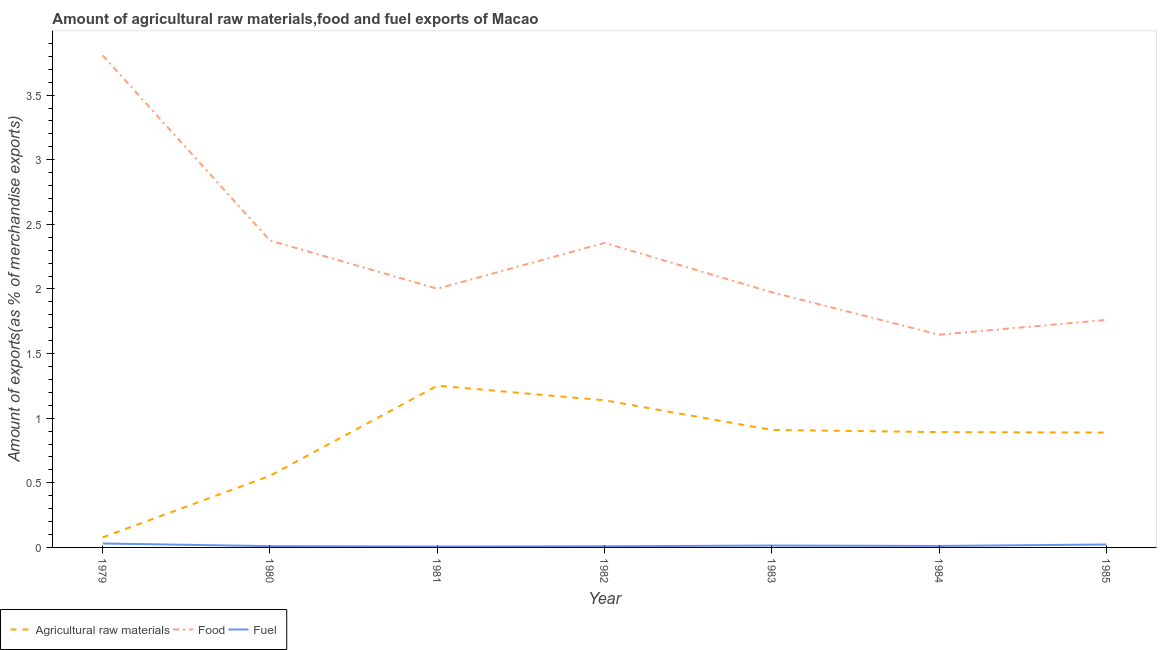Does the line corresponding to percentage of fuel exports intersect with the line corresponding to percentage of raw materials exports?
Offer a very short reply. No. Is the number of lines equal to the number of legend labels?
Your answer should be very brief. Yes. What is the percentage of food exports in 1984?
Offer a terse response. 1.65. Across all years, what is the maximum percentage of fuel exports?
Give a very brief answer. 0.03. Across all years, what is the minimum percentage of fuel exports?
Keep it short and to the point. 0.01. In which year was the percentage of food exports minimum?
Provide a short and direct response. 1984. What is the total percentage of fuel exports in the graph?
Give a very brief answer. 0.1. What is the difference between the percentage of fuel exports in 1982 and that in 1983?
Make the answer very short. -0.01. What is the difference between the percentage of food exports in 1984 and the percentage of raw materials exports in 1979?
Your answer should be very brief. 1.57. What is the average percentage of food exports per year?
Provide a succinct answer. 2.27. In the year 1983, what is the difference between the percentage of raw materials exports and percentage of fuel exports?
Offer a terse response. 0.89. In how many years, is the percentage of raw materials exports greater than 3.5 %?
Provide a succinct answer. 0. What is the ratio of the percentage of fuel exports in 1984 to that in 1985?
Offer a terse response. 0.5. Is the percentage of raw materials exports in 1980 less than that in 1985?
Make the answer very short. Yes. Is the difference between the percentage of fuel exports in 1980 and 1982 greater than the difference between the percentage of raw materials exports in 1980 and 1982?
Your response must be concise. Yes. What is the difference between the highest and the second highest percentage of fuel exports?
Make the answer very short. 0.01. What is the difference between the highest and the lowest percentage of raw materials exports?
Offer a very short reply. 1.17. Does the percentage of fuel exports monotonically increase over the years?
Make the answer very short. No. Is the percentage of food exports strictly greater than the percentage of raw materials exports over the years?
Your response must be concise. Yes. Is the percentage of food exports strictly less than the percentage of raw materials exports over the years?
Offer a very short reply. No. How many lines are there?
Give a very brief answer. 3. How many years are there in the graph?
Keep it short and to the point. 7. What is the difference between two consecutive major ticks on the Y-axis?
Your response must be concise. 0.5. Does the graph contain any zero values?
Provide a succinct answer. No. How many legend labels are there?
Make the answer very short. 3. How are the legend labels stacked?
Provide a succinct answer. Horizontal. What is the title of the graph?
Your response must be concise. Amount of agricultural raw materials,food and fuel exports of Macao. Does "Ages 60+" appear as one of the legend labels in the graph?
Provide a succinct answer. No. What is the label or title of the X-axis?
Provide a short and direct response. Year. What is the label or title of the Y-axis?
Keep it short and to the point. Amount of exports(as % of merchandise exports). What is the Amount of exports(as % of merchandise exports) in Agricultural raw materials in 1979?
Provide a succinct answer. 0.08. What is the Amount of exports(as % of merchandise exports) of Food in 1979?
Give a very brief answer. 3.81. What is the Amount of exports(as % of merchandise exports) in Fuel in 1979?
Ensure brevity in your answer.  0.03. What is the Amount of exports(as % of merchandise exports) in Agricultural raw materials in 1980?
Your answer should be compact. 0.55. What is the Amount of exports(as % of merchandise exports) of Food in 1980?
Offer a very short reply. 2.38. What is the Amount of exports(as % of merchandise exports) in Fuel in 1980?
Your response must be concise. 0.01. What is the Amount of exports(as % of merchandise exports) in Agricultural raw materials in 1981?
Provide a succinct answer. 1.25. What is the Amount of exports(as % of merchandise exports) of Food in 1981?
Keep it short and to the point. 2. What is the Amount of exports(as % of merchandise exports) in Fuel in 1981?
Provide a short and direct response. 0.01. What is the Amount of exports(as % of merchandise exports) of Agricultural raw materials in 1982?
Offer a terse response. 1.14. What is the Amount of exports(as % of merchandise exports) of Food in 1982?
Your answer should be compact. 2.36. What is the Amount of exports(as % of merchandise exports) in Fuel in 1982?
Offer a terse response. 0.01. What is the Amount of exports(as % of merchandise exports) in Agricultural raw materials in 1983?
Your answer should be compact. 0.91. What is the Amount of exports(as % of merchandise exports) of Food in 1983?
Make the answer very short. 1.97. What is the Amount of exports(as % of merchandise exports) of Fuel in 1983?
Provide a succinct answer. 0.01. What is the Amount of exports(as % of merchandise exports) of Agricultural raw materials in 1984?
Make the answer very short. 0.89. What is the Amount of exports(as % of merchandise exports) of Food in 1984?
Your answer should be very brief. 1.65. What is the Amount of exports(as % of merchandise exports) of Fuel in 1984?
Make the answer very short. 0.01. What is the Amount of exports(as % of merchandise exports) in Agricultural raw materials in 1985?
Ensure brevity in your answer.  0.89. What is the Amount of exports(as % of merchandise exports) in Food in 1985?
Your answer should be very brief. 1.76. What is the Amount of exports(as % of merchandise exports) of Fuel in 1985?
Provide a succinct answer. 0.02. Across all years, what is the maximum Amount of exports(as % of merchandise exports) in Agricultural raw materials?
Offer a terse response. 1.25. Across all years, what is the maximum Amount of exports(as % of merchandise exports) of Food?
Ensure brevity in your answer.  3.81. Across all years, what is the maximum Amount of exports(as % of merchandise exports) of Fuel?
Make the answer very short. 0.03. Across all years, what is the minimum Amount of exports(as % of merchandise exports) of Agricultural raw materials?
Offer a terse response. 0.08. Across all years, what is the minimum Amount of exports(as % of merchandise exports) in Food?
Keep it short and to the point. 1.65. Across all years, what is the minimum Amount of exports(as % of merchandise exports) of Fuel?
Give a very brief answer. 0.01. What is the total Amount of exports(as % of merchandise exports) in Agricultural raw materials in the graph?
Keep it short and to the point. 5.71. What is the total Amount of exports(as % of merchandise exports) in Food in the graph?
Ensure brevity in your answer.  15.92. What is the total Amount of exports(as % of merchandise exports) in Fuel in the graph?
Your answer should be compact. 0.1. What is the difference between the Amount of exports(as % of merchandise exports) of Agricultural raw materials in 1979 and that in 1980?
Your answer should be compact. -0.48. What is the difference between the Amount of exports(as % of merchandise exports) of Food in 1979 and that in 1980?
Provide a succinct answer. 1.43. What is the difference between the Amount of exports(as % of merchandise exports) in Fuel in 1979 and that in 1980?
Keep it short and to the point. 0.02. What is the difference between the Amount of exports(as % of merchandise exports) in Agricultural raw materials in 1979 and that in 1981?
Your answer should be compact. -1.17. What is the difference between the Amount of exports(as % of merchandise exports) of Food in 1979 and that in 1981?
Your answer should be compact. 1.81. What is the difference between the Amount of exports(as % of merchandise exports) in Fuel in 1979 and that in 1981?
Give a very brief answer. 0.02. What is the difference between the Amount of exports(as % of merchandise exports) in Agricultural raw materials in 1979 and that in 1982?
Ensure brevity in your answer.  -1.06. What is the difference between the Amount of exports(as % of merchandise exports) of Food in 1979 and that in 1982?
Your answer should be compact. 1.45. What is the difference between the Amount of exports(as % of merchandise exports) of Fuel in 1979 and that in 1982?
Offer a very short reply. 0.02. What is the difference between the Amount of exports(as % of merchandise exports) in Agricultural raw materials in 1979 and that in 1983?
Your response must be concise. -0.83. What is the difference between the Amount of exports(as % of merchandise exports) of Food in 1979 and that in 1983?
Your answer should be very brief. 1.83. What is the difference between the Amount of exports(as % of merchandise exports) of Fuel in 1979 and that in 1983?
Provide a succinct answer. 0.02. What is the difference between the Amount of exports(as % of merchandise exports) in Agricultural raw materials in 1979 and that in 1984?
Ensure brevity in your answer.  -0.81. What is the difference between the Amount of exports(as % of merchandise exports) in Food in 1979 and that in 1984?
Your response must be concise. 2.16. What is the difference between the Amount of exports(as % of merchandise exports) in Fuel in 1979 and that in 1984?
Your answer should be very brief. 0.02. What is the difference between the Amount of exports(as % of merchandise exports) of Agricultural raw materials in 1979 and that in 1985?
Your answer should be compact. -0.81. What is the difference between the Amount of exports(as % of merchandise exports) of Food in 1979 and that in 1985?
Keep it short and to the point. 2.05. What is the difference between the Amount of exports(as % of merchandise exports) of Fuel in 1979 and that in 1985?
Offer a terse response. 0.01. What is the difference between the Amount of exports(as % of merchandise exports) of Agricultural raw materials in 1980 and that in 1981?
Ensure brevity in your answer.  -0.7. What is the difference between the Amount of exports(as % of merchandise exports) in Food in 1980 and that in 1981?
Give a very brief answer. 0.37. What is the difference between the Amount of exports(as % of merchandise exports) in Fuel in 1980 and that in 1981?
Your answer should be very brief. 0. What is the difference between the Amount of exports(as % of merchandise exports) in Agricultural raw materials in 1980 and that in 1982?
Offer a very short reply. -0.58. What is the difference between the Amount of exports(as % of merchandise exports) in Food in 1980 and that in 1982?
Offer a very short reply. 0.02. What is the difference between the Amount of exports(as % of merchandise exports) of Fuel in 1980 and that in 1982?
Provide a succinct answer. 0. What is the difference between the Amount of exports(as % of merchandise exports) of Agricultural raw materials in 1980 and that in 1983?
Offer a very short reply. -0.36. What is the difference between the Amount of exports(as % of merchandise exports) in Food in 1980 and that in 1983?
Provide a succinct answer. 0.4. What is the difference between the Amount of exports(as % of merchandise exports) of Fuel in 1980 and that in 1983?
Provide a succinct answer. -0. What is the difference between the Amount of exports(as % of merchandise exports) of Agricultural raw materials in 1980 and that in 1984?
Provide a short and direct response. -0.34. What is the difference between the Amount of exports(as % of merchandise exports) in Food in 1980 and that in 1984?
Your answer should be very brief. 0.73. What is the difference between the Amount of exports(as % of merchandise exports) of Fuel in 1980 and that in 1984?
Give a very brief answer. -0. What is the difference between the Amount of exports(as % of merchandise exports) in Agricultural raw materials in 1980 and that in 1985?
Offer a very short reply. -0.33. What is the difference between the Amount of exports(as % of merchandise exports) of Food in 1980 and that in 1985?
Provide a succinct answer. 0.61. What is the difference between the Amount of exports(as % of merchandise exports) in Fuel in 1980 and that in 1985?
Your response must be concise. -0.01. What is the difference between the Amount of exports(as % of merchandise exports) of Agricultural raw materials in 1981 and that in 1982?
Your response must be concise. 0.11. What is the difference between the Amount of exports(as % of merchandise exports) in Food in 1981 and that in 1982?
Make the answer very short. -0.35. What is the difference between the Amount of exports(as % of merchandise exports) of Fuel in 1981 and that in 1982?
Give a very brief answer. -0. What is the difference between the Amount of exports(as % of merchandise exports) of Agricultural raw materials in 1981 and that in 1983?
Your response must be concise. 0.34. What is the difference between the Amount of exports(as % of merchandise exports) in Food in 1981 and that in 1983?
Make the answer very short. 0.03. What is the difference between the Amount of exports(as % of merchandise exports) of Fuel in 1981 and that in 1983?
Your answer should be very brief. -0.01. What is the difference between the Amount of exports(as % of merchandise exports) in Agricultural raw materials in 1981 and that in 1984?
Your answer should be very brief. 0.36. What is the difference between the Amount of exports(as % of merchandise exports) of Food in 1981 and that in 1984?
Give a very brief answer. 0.36. What is the difference between the Amount of exports(as % of merchandise exports) in Fuel in 1981 and that in 1984?
Keep it short and to the point. -0. What is the difference between the Amount of exports(as % of merchandise exports) of Agricultural raw materials in 1981 and that in 1985?
Ensure brevity in your answer.  0.36. What is the difference between the Amount of exports(as % of merchandise exports) of Food in 1981 and that in 1985?
Offer a very short reply. 0.24. What is the difference between the Amount of exports(as % of merchandise exports) in Fuel in 1981 and that in 1985?
Offer a very short reply. -0.02. What is the difference between the Amount of exports(as % of merchandise exports) in Agricultural raw materials in 1982 and that in 1983?
Offer a very short reply. 0.23. What is the difference between the Amount of exports(as % of merchandise exports) of Food in 1982 and that in 1983?
Offer a terse response. 0.38. What is the difference between the Amount of exports(as % of merchandise exports) in Fuel in 1982 and that in 1983?
Provide a succinct answer. -0.01. What is the difference between the Amount of exports(as % of merchandise exports) of Agricultural raw materials in 1982 and that in 1984?
Give a very brief answer. 0.25. What is the difference between the Amount of exports(as % of merchandise exports) of Food in 1982 and that in 1984?
Your answer should be very brief. 0.71. What is the difference between the Amount of exports(as % of merchandise exports) of Fuel in 1982 and that in 1984?
Ensure brevity in your answer.  -0. What is the difference between the Amount of exports(as % of merchandise exports) of Agricultural raw materials in 1982 and that in 1985?
Provide a succinct answer. 0.25. What is the difference between the Amount of exports(as % of merchandise exports) of Food in 1982 and that in 1985?
Keep it short and to the point. 0.6. What is the difference between the Amount of exports(as % of merchandise exports) of Fuel in 1982 and that in 1985?
Keep it short and to the point. -0.01. What is the difference between the Amount of exports(as % of merchandise exports) of Agricultural raw materials in 1983 and that in 1984?
Ensure brevity in your answer.  0.02. What is the difference between the Amount of exports(as % of merchandise exports) in Food in 1983 and that in 1984?
Your response must be concise. 0.33. What is the difference between the Amount of exports(as % of merchandise exports) in Fuel in 1983 and that in 1984?
Provide a short and direct response. 0. What is the difference between the Amount of exports(as % of merchandise exports) in Agricultural raw materials in 1983 and that in 1985?
Give a very brief answer. 0.02. What is the difference between the Amount of exports(as % of merchandise exports) in Food in 1983 and that in 1985?
Provide a succinct answer. 0.21. What is the difference between the Amount of exports(as % of merchandise exports) in Fuel in 1983 and that in 1985?
Give a very brief answer. -0.01. What is the difference between the Amount of exports(as % of merchandise exports) in Agricultural raw materials in 1984 and that in 1985?
Your response must be concise. 0. What is the difference between the Amount of exports(as % of merchandise exports) in Food in 1984 and that in 1985?
Keep it short and to the point. -0.11. What is the difference between the Amount of exports(as % of merchandise exports) of Fuel in 1984 and that in 1985?
Your response must be concise. -0.01. What is the difference between the Amount of exports(as % of merchandise exports) in Agricultural raw materials in 1979 and the Amount of exports(as % of merchandise exports) in Food in 1980?
Offer a terse response. -2.3. What is the difference between the Amount of exports(as % of merchandise exports) in Agricultural raw materials in 1979 and the Amount of exports(as % of merchandise exports) in Fuel in 1980?
Offer a terse response. 0.07. What is the difference between the Amount of exports(as % of merchandise exports) of Food in 1979 and the Amount of exports(as % of merchandise exports) of Fuel in 1980?
Your answer should be very brief. 3.8. What is the difference between the Amount of exports(as % of merchandise exports) of Agricultural raw materials in 1979 and the Amount of exports(as % of merchandise exports) of Food in 1981?
Your answer should be compact. -1.92. What is the difference between the Amount of exports(as % of merchandise exports) in Agricultural raw materials in 1979 and the Amount of exports(as % of merchandise exports) in Fuel in 1981?
Give a very brief answer. 0.07. What is the difference between the Amount of exports(as % of merchandise exports) in Food in 1979 and the Amount of exports(as % of merchandise exports) in Fuel in 1981?
Give a very brief answer. 3.8. What is the difference between the Amount of exports(as % of merchandise exports) of Agricultural raw materials in 1979 and the Amount of exports(as % of merchandise exports) of Food in 1982?
Give a very brief answer. -2.28. What is the difference between the Amount of exports(as % of merchandise exports) in Agricultural raw materials in 1979 and the Amount of exports(as % of merchandise exports) in Fuel in 1982?
Your answer should be compact. 0.07. What is the difference between the Amount of exports(as % of merchandise exports) of Food in 1979 and the Amount of exports(as % of merchandise exports) of Fuel in 1982?
Make the answer very short. 3.8. What is the difference between the Amount of exports(as % of merchandise exports) in Agricultural raw materials in 1979 and the Amount of exports(as % of merchandise exports) in Food in 1983?
Offer a terse response. -1.9. What is the difference between the Amount of exports(as % of merchandise exports) in Agricultural raw materials in 1979 and the Amount of exports(as % of merchandise exports) in Fuel in 1983?
Offer a terse response. 0.06. What is the difference between the Amount of exports(as % of merchandise exports) of Food in 1979 and the Amount of exports(as % of merchandise exports) of Fuel in 1983?
Give a very brief answer. 3.79. What is the difference between the Amount of exports(as % of merchandise exports) of Agricultural raw materials in 1979 and the Amount of exports(as % of merchandise exports) of Food in 1984?
Your answer should be compact. -1.57. What is the difference between the Amount of exports(as % of merchandise exports) in Agricultural raw materials in 1979 and the Amount of exports(as % of merchandise exports) in Fuel in 1984?
Make the answer very short. 0.07. What is the difference between the Amount of exports(as % of merchandise exports) of Food in 1979 and the Amount of exports(as % of merchandise exports) of Fuel in 1984?
Provide a succinct answer. 3.8. What is the difference between the Amount of exports(as % of merchandise exports) in Agricultural raw materials in 1979 and the Amount of exports(as % of merchandise exports) in Food in 1985?
Offer a terse response. -1.68. What is the difference between the Amount of exports(as % of merchandise exports) in Agricultural raw materials in 1979 and the Amount of exports(as % of merchandise exports) in Fuel in 1985?
Your answer should be compact. 0.06. What is the difference between the Amount of exports(as % of merchandise exports) of Food in 1979 and the Amount of exports(as % of merchandise exports) of Fuel in 1985?
Offer a terse response. 3.79. What is the difference between the Amount of exports(as % of merchandise exports) in Agricultural raw materials in 1980 and the Amount of exports(as % of merchandise exports) in Food in 1981?
Offer a terse response. -1.45. What is the difference between the Amount of exports(as % of merchandise exports) of Agricultural raw materials in 1980 and the Amount of exports(as % of merchandise exports) of Fuel in 1981?
Offer a terse response. 0.55. What is the difference between the Amount of exports(as % of merchandise exports) of Food in 1980 and the Amount of exports(as % of merchandise exports) of Fuel in 1981?
Your answer should be compact. 2.37. What is the difference between the Amount of exports(as % of merchandise exports) of Agricultural raw materials in 1980 and the Amount of exports(as % of merchandise exports) of Food in 1982?
Ensure brevity in your answer.  -1.8. What is the difference between the Amount of exports(as % of merchandise exports) in Agricultural raw materials in 1980 and the Amount of exports(as % of merchandise exports) in Fuel in 1982?
Keep it short and to the point. 0.54. What is the difference between the Amount of exports(as % of merchandise exports) in Food in 1980 and the Amount of exports(as % of merchandise exports) in Fuel in 1982?
Ensure brevity in your answer.  2.37. What is the difference between the Amount of exports(as % of merchandise exports) in Agricultural raw materials in 1980 and the Amount of exports(as % of merchandise exports) in Food in 1983?
Offer a terse response. -1.42. What is the difference between the Amount of exports(as % of merchandise exports) in Agricultural raw materials in 1980 and the Amount of exports(as % of merchandise exports) in Fuel in 1983?
Provide a short and direct response. 0.54. What is the difference between the Amount of exports(as % of merchandise exports) in Food in 1980 and the Amount of exports(as % of merchandise exports) in Fuel in 1983?
Offer a terse response. 2.36. What is the difference between the Amount of exports(as % of merchandise exports) of Agricultural raw materials in 1980 and the Amount of exports(as % of merchandise exports) of Food in 1984?
Give a very brief answer. -1.09. What is the difference between the Amount of exports(as % of merchandise exports) of Agricultural raw materials in 1980 and the Amount of exports(as % of merchandise exports) of Fuel in 1984?
Provide a succinct answer. 0.54. What is the difference between the Amount of exports(as % of merchandise exports) of Food in 1980 and the Amount of exports(as % of merchandise exports) of Fuel in 1984?
Offer a very short reply. 2.36. What is the difference between the Amount of exports(as % of merchandise exports) in Agricultural raw materials in 1980 and the Amount of exports(as % of merchandise exports) in Food in 1985?
Provide a succinct answer. -1.21. What is the difference between the Amount of exports(as % of merchandise exports) of Agricultural raw materials in 1980 and the Amount of exports(as % of merchandise exports) of Fuel in 1985?
Your answer should be very brief. 0.53. What is the difference between the Amount of exports(as % of merchandise exports) in Food in 1980 and the Amount of exports(as % of merchandise exports) in Fuel in 1985?
Provide a succinct answer. 2.35. What is the difference between the Amount of exports(as % of merchandise exports) in Agricultural raw materials in 1981 and the Amount of exports(as % of merchandise exports) in Food in 1982?
Give a very brief answer. -1.1. What is the difference between the Amount of exports(as % of merchandise exports) of Agricultural raw materials in 1981 and the Amount of exports(as % of merchandise exports) of Fuel in 1982?
Keep it short and to the point. 1.24. What is the difference between the Amount of exports(as % of merchandise exports) in Food in 1981 and the Amount of exports(as % of merchandise exports) in Fuel in 1982?
Your response must be concise. 1.99. What is the difference between the Amount of exports(as % of merchandise exports) in Agricultural raw materials in 1981 and the Amount of exports(as % of merchandise exports) in Food in 1983?
Provide a short and direct response. -0.72. What is the difference between the Amount of exports(as % of merchandise exports) in Agricultural raw materials in 1981 and the Amount of exports(as % of merchandise exports) in Fuel in 1983?
Offer a terse response. 1.24. What is the difference between the Amount of exports(as % of merchandise exports) in Food in 1981 and the Amount of exports(as % of merchandise exports) in Fuel in 1983?
Offer a terse response. 1.99. What is the difference between the Amount of exports(as % of merchandise exports) in Agricultural raw materials in 1981 and the Amount of exports(as % of merchandise exports) in Food in 1984?
Give a very brief answer. -0.39. What is the difference between the Amount of exports(as % of merchandise exports) in Agricultural raw materials in 1981 and the Amount of exports(as % of merchandise exports) in Fuel in 1984?
Provide a short and direct response. 1.24. What is the difference between the Amount of exports(as % of merchandise exports) of Food in 1981 and the Amount of exports(as % of merchandise exports) of Fuel in 1984?
Give a very brief answer. 1.99. What is the difference between the Amount of exports(as % of merchandise exports) of Agricultural raw materials in 1981 and the Amount of exports(as % of merchandise exports) of Food in 1985?
Keep it short and to the point. -0.51. What is the difference between the Amount of exports(as % of merchandise exports) of Agricultural raw materials in 1981 and the Amount of exports(as % of merchandise exports) of Fuel in 1985?
Keep it short and to the point. 1.23. What is the difference between the Amount of exports(as % of merchandise exports) in Food in 1981 and the Amount of exports(as % of merchandise exports) in Fuel in 1985?
Keep it short and to the point. 1.98. What is the difference between the Amount of exports(as % of merchandise exports) of Agricultural raw materials in 1982 and the Amount of exports(as % of merchandise exports) of Food in 1983?
Keep it short and to the point. -0.84. What is the difference between the Amount of exports(as % of merchandise exports) in Agricultural raw materials in 1982 and the Amount of exports(as % of merchandise exports) in Fuel in 1983?
Your response must be concise. 1.12. What is the difference between the Amount of exports(as % of merchandise exports) of Food in 1982 and the Amount of exports(as % of merchandise exports) of Fuel in 1983?
Offer a very short reply. 2.34. What is the difference between the Amount of exports(as % of merchandise exports) of Agricultural raw materials in 1982 and the Amount of exports(as % of merchandise exports) of Food in 1984?
Ensure brevity in your answer.  -0.51. What is the difference between the Amount of exports(as % of merchandise exports) of Agricultural raw materials in 1982 and the Amount of exports(as % of merchandise exports) of Fuel in 1984?
Ensure brevity in your answer.  1.13. What is the difference between the Amount of exports(as % of merchandise exports) of Food in 1982 and the Amount of exports(as % of merchandise exports) of Fuel in 1984?
Offer a very short reply. 2.35. What is the difference between the Amount of exports(as % of merchandise exports) in Agricultural raw materials in 1982 and the Amount of exports(as % of merchandise exports) in Food in 1985?
Provide a short and direct response. -0.62. What is the difference between the Amount of exports(as % of merchandise exports) of Agricultural raw materials in 1982 and the Amount of exports(as % of merchandise exports) of Fuel in 1985?
Give a very brief answer. 1.12. What is the difference between the Amount of exports(as % of merchandise exports) of Food in 1982 and the Amount of exports(as % of merchandise exports) of Fuel in 1985?
Your answer should be very brief. 2.33. What is the difference between the Amount of exports(as % of merchandise exports) of Agricultural raw materials in 1983 and the Amount of exports(as % of merchandise exports) of Food in 1984?
Provide a short and direct response. -0.74. What is the difference between the Amount of exports(as % of merchandise exports) in Agricultural raw materials in 1983 and the Amount of exports(as % of merchandise exports) in Fuel in 1984?
Provide a short and direct response. 0.9. What is the difference between the Amount of exports(as % of merchandise exports) of Food in 1983 and the Amount of exports(as % of merchandise exports) of Fuel in 1984?
Offer a terse response. 1.96. What is the difference between the Amount of exports(as % of merchandise exports) in Agricultural raw materials in 1983 and the Amount of exports(as % of merchandise exports) in Food in 1985?
Keep it short and to the point. -0.85. What is the difference between the Amount of exports(as % of merchandise exports) of Agricultural raw materials in 1983 and the Amount of exports(as % of merchandise exports) of Fuel in 1985?
Ensure brevity in your answer.  0.89. What is the difference between the Amount of exports(as % of merchandise exports) of Food in 1983 and the Amount of exports(as % of merchandise exports) of Fuel in 1985?
Provide a succinct answer. 1.95. What is the difference between the Amount of exports(as % of merchandise exports) in Agricultural raw materials in 1984 and the Amount of exports(as % of merchandise exports) in Food in 1985?
Your answer should be very brief. -0.87. What is the difference between the Amount of exports(as % of merchandise exports) of Agricultural raw materials in 1984 and the Amount of exports(as % of merchandise exports) of Fuel in 1985?
Offer a very short reply. 0.87. What is the difference between the Amount of exports(as % of merchandise exports) of Food in 1984 and the Amount of exports(as % of merchandise exports) of Fuel in 1985?
Your response must be concise. 1.62. What is the average Amount of exports(as % of merchandise exports) of Agricultural raw materials per year?
Keep it short and to the point. 0.82. What is the average Amount of exports(as % of merchandise exports) of Food per year?
Give a very brief answer. 2.27. What is the average Amount of exports(as % of merchandise exports) in Fuel per year?
Keep it short and to the point. 0.01. In the year 1979, what is the difference between the Amount of exports(as % of merchandise exports) of Agricultural raw materials and Amount of exports(as % of merchandise exports) of Food?
Offer a very short reply. -3.73. In the year 1979, what is the difference between the Amount of exports(as % of merchandise exports) in Agricultural raw materials and Amount of exports(as % of merchandise exports) in Fuel?
Your response must be concise. 0.05. In the year 1979, what is the difference between the Amount of exports(as % of merchandise exports) of Food and Amount of exports(as % of merchandise exports) of Fuel?
Provide a succinct answer. 3.78. In the year 1980, what is the difference between the Amount of exports(as % of merchandise exports) in Agricultural raw materials and Amount of exports(as % of merchandise exports) in Food?
Make the answer very short. -1.82. In the year 1980, what is the difference between the Amount of exports(as % of merchandise exports) of Agricultural raw materials and Amount of exports(as % of merchandise exports) of Fuel?
Offer a terse response. 0.54. In the year 1980, what is the difference between the Amount of exports(as % of merchandise exports) in Food and Amount of exports(as % of merchandise exports) in Fuel?
Your answer should be very brief. 2.37. In the year 1981, what is the difference between the Amount of exports(as % of merchandise exports) of Agricultural raw materials and Amount of exports(as % of merchandise exports) of Food?
Keep it short and to the point. -0.75. In the year 1981, what is the difference between the Amount of exports(as % of merchandise exports) in Agricultural raw materials and Amount of exports(as % of merchandise exports) in Fuel?
Your answer should be very brief. 1.24. In the year 1981, what is the difference between the Amount of exports(as % of merchandise exports) of Food and Amount of exports(as % of merchandise exports) of Fuel?
Offer a terse response. 2. In the year 1982, what is the difference between the Amount of exports(as % of merchandise exports) in Agricultural raw materials and Amount of exports(as % of merchandise exports) in Food?
Make the answer very short. -1.22. In the year 1982, what is the difference between the Amount of exports(as % of merchandise exports) in Agricultural raw materials and Amount of exports(as % of merchandise exports) in Fuel?
Provide a short and direct response. 1.13. In the year 1982, what is the difference between the Amount of exports(as % of merchandise exports) in Food and Amount of exports(as % of merchandise exports) in Fuel?
Ensure brevity in your answer.  2.35. In the year 1983, what is the difference between the Amount of exports(as % of merchandise exports) in Agricultural raw materials and Amount of exports(as % of merchandise exports) in Food?
Your response must be concise. -1.07. In the year 1983, what is the difference between the Amount of exports(as % of merchandise exports) in Agricultural raw materials and Amount of exports(as % of merchandise exports) in Fuel?
Keep it short and to the point. 0.89. In the year 1983, what is the difference between the Amount of exports(as % of merchandise exports) in Food and Amount of exports(as % of merchandise exports) in Fuel?
Offer a very short reply. 1.96. In the year 1984, what is the difference between the Amount of exports(as % of merchandise exports) of Agricultural raw materials and Amount of exports(as % of merchandise exports) of Food?
Your answer should be very brief. -0.75. In the year 1984, what is the difference between the Amount of exports(as % of merchandise exports) of Agricultural raw materials and Amount of exports(as % of merchandise exports) of Fuel?
Provide a succinct answer. 0.88. In the year 1984, what is the difference between the Amount of exports(as % of merchandise exports) in Food and Amount of exports(as % of merchandise exports) in Fuel?
Provide a short and direct response. 1.63. In the year 1985, what is the difference between the Amount of exports(as % of merchandise exports) in Agricultural raw materials and Amount of exports(as % of merchandise exports) in Food?
Keep it short and to the point. -0.87. In the year 1985, what is the difference between the Amount of exports(as % of merchandise exports) of Agricultural raw materials and Amount of exports(as % of merchandise exports) of Fuel?
Ensure brevity in your answer.  0.87. In the year 1985, what is the difference between the Amount of exports(as % of merchandise exports) in Food and Amount of exports(as % of merchandise exports) in Fuel?
Give a very brief answer. 1.74. What is the ratio of the Amount of exports(as % of merchandise exports) of Agricultural raw materials in 1979 to that in 1980?
Offer a terse response. 0.14. What is the ratio of the Amount of exports(as % of merchandise exports) in Food in 1979 to that in 1980?
Ensure brevity in your answer.  1.6. What is the ratio of the Amount of exports(as % of merchandise exports) of Fuel in 1979 to that in 1980?
Your answer should be compact. 3.03. What is the ratio of the Amount of exports(as % of merchandise exports) in Agricultural raw materials in 1979 to that in 1981?
Offer a very short reply. 0.06. What is the ratio of the Amount of exports(as % of merchandise exports) of Food in 1979 to that in 1981?
Your answer should be very brief. 1.9. What is the ratio of the Amount of exports(as % of merchandise exports) of Fuel in 1979 to that in 1981?
Your answer should be compact. 4.42. What is the ratio of the Amount of exports(as % of merchandise exports) of Agricultural raw materials in 1979 to that in 1982?
Make the answer very short. 0.07. What is the ratio of the Amount of exports(as % of merchandise exports) in Food in 1979 to that in 1982?
Give a very brief answer. 1.62. What is the ratio of the Amount of exports(as % of merchandise exports) in Fuel in 1979 to that in 1982?
Keep it short and to the point. 3.4. What is the ratio of the Amount of exports(as % of merchandise exports) in Agricultural raw materials in 1979 to that in 1983?
Make the answer very short. 0.09. What is the ratio of the Amount of exports(as % of merchandise exports) of Food in 1979 to that in 1983?
Give a very brief answer. 1.93. What is the ratio of the Amount of exports(as % of merchandise exports) in Fuel in 1979 to that in 1983?
Your response must be concise. 2.09. What is the ratio of the Amount of exports(as % of merchandise exports) in Agricultural raw materials in 1979 to that in 1984?
Make the answer very short. 0.09. What is the ratio of the Amount of exports(as % of merchandise exports) in Food in 1979 to that in 1984?
Offer a very short reply. 2.31. What is the ratio of the Amount of exports(as % of merchandise exports) of Fuel in 1979 to that in 1984?
Provide a short and direct response. 2.68. What is the ratio of the Amount of exports(as % of merchandise exports) of Agricultural raw materials in 1979 to that in 1985?
Provide a short and direct response. 0.09. What is the ratio of the Amount of exports(as % of merchandise exports) in Food in 1979 to that in 1985?
Give a very brief answer. 2.16. What is the ratio of the Amount of exports(as % of merchandise exports) of Fuel in 1979 to that in 1985?
Ensure brevity in your answer.  1.34. What is the ratio of the Amount of exports(as % of merchandise exports) in Agricultural raw materials in 1980 to that in 1981?
Your answer should be very brief. 0.44. What is the ratio of the Amount of exports(as % of merchandise exports) in Food in 1980 to that in 1981?
Offer a terse response. 1.19. What is the ratio of the Amount of exports(as % of merchandise exports) of Fuel in 1980 to that in 1981?
Give a very brief answer. 1.46. What is the ratio of the Amount of exports(as % of merchandise exports) of Agricultural raw materials in 1980 to that in 1982?
Make the answer very short. 0.49. What is the ratio of the Amount of exports(as % of merchandise exports) in Fuel in 1980 to that in 1982?
Your answer should be compact. 1.12. What is the ratio of the Amount of exports(as % of merchandise exports) of Agricultural raw materials in 1980 to that in 1983?
Ensure brevity in your answer.  0.61. What is the ratio of the Amount of exports(as % of merchandise exports) of Food in 1980 to that in 1983?
Your answer should be compact. 1.2. What is the ratio of the Amount of exports(as % of merchandise exports) in Fuel in 1980 to that in 1983?
Make the answer very short. 0.69. What is the ratio of the Amount of exports(as % of merchandise exports) of Agricultural raw materials in 1980 to that in 1984?
Provide a short and direct response. 0.62. What is the ratio of the Amount of exports(as % of merchandise exports) of Food in 1980 to that in 1984?
Give a very brief answer. 1.44. What is the ratio of the Amount of exports(as % of merchandise exports) in Fuel in 1980 to that in 1984?
Provide a short and direct response. 0.88. What is the ratio of the Amount of exports(as % of merchandise exports) of Agricultural raw materials in 1980 to that in 1985?
Your answer should be very brief. 0.62. What is the ratio of the Amount of exports(as % of merchandise exports) in Food in 1980 to that in 1985?
Your answer should be compact. 1.35. What is the ratio of the Amount of exports(as % of merchandise exports) of Fuel in 1980 to that in 1985?
Your answer should be very brief. 0.44. What is the ratio of the Amount of exports(as % of merchandise exports) in Agricultural raw materials in 1981 to that in 1982?
Your response must be concise. 1.1. What is the ratio of the Amount of exports(as % of merchandise exports) of Food in 1981 to that in 1982?
Provide a succinct answer. 0.85. What is the ratio of the Amount of exports(as % of merchandise exports) of Fuel in 1981 to that in 1982?
Your answer should be compact. 0.77. What is the ratio of the Amount of exports(as % of merchandise exports) of Agricultural raw materials in 1981 to that in 1983?
Keep it short and to the point. 1.38. What is the ratio of the Amount of exports(as % of merchandise exports) of Food in 1981 to that in 1983?
Ensure brevity in your answer.  1.01. What is the ratio of the Amount of exports(as % of merchandise exports) in Fuel in 1981 to that in 1983?
Your answer should be very brief. 0.47. What is the ratio of the Amount of exports(as % of merchandise exports) in Agricultural raw materials in 1981 to that in 1984?
Your response must be concise. 1.4. What is the ratio of the Amount of exports(as % of merchandise exports) of Food in 1981 to that in 1984?
Offer a terse response. 1.22. What is the ratio of the Amount of exports(as % of merchandise exports) of Fuel in 1981 to that in 1984?
Offer a terse response. 0.61. What is the ratio of the Amount of exports(as % of merchandise exports) in Agricultural raw materials in 1981 to that in 1985?
Give a very brief answer. 1.41. What is the ratio of the Amount of exports(as % of merchandise exports) in Food in 1981 to that in 1985?
Your answer should be very brief. 1.14. What is the ratio of the Amount of exports(as % of merchandise exports) of Fuel in 1981 to that in 1985?
Provide a short and direct response. 0.3. What is the ratio of the Amount of exports(as % of merchandise exports) in Agricultural raw materials in 1982 to that in 1983?
Offer a terse response. 1.25. What is the ratio of the Amount of exports(as % of merchandise exports) in Food in 1982 to that in 1983?
Your answer should be compact. 1.19. What is the ratio of the Amount of exports(as % of merchandise exports) of Fuel in 1982 to that in 1983?
Make the answer very short. 0.61. What is the ratio of the Amount of exports(as % of merchandise exports) in Agricultural raw materials in 1982 to that in 1984?
Your response must be concise. 1.28. What is the ratio of the Amount of exports(as % of merchandise exports) of Food in 1982 to that in 1984?
Offer a very short reply. 1.43. What is the ratio of the Amount of exports(as % of merchandise exports) of Fuel in 1982 to that in 1984?
Your answer should be very brief. 0.79. What is the ratio of the Amount of exports(as % of merchandise exports) in Agricultural raw materials in 1982 to that in 1985?
Your response must be concise. 1.28. What is the ratio of the Amount of exports(as % of merchandise exports) of Food in 1982 to that in 1985?
Provide a succinct answer. 1.34. What is the ratio of the Amount of exports(as % of merchandise exports) in Fuel in 1982 to that in 1985?
Offer a very short reply. 0.4. What is the ratio of the Amount of exports(as % of merchandise exports) of Food in 1983 to that in 1984?
Your answer should be compact. 1.2. What is the ratio of the Amount of exports(as % of merchandise exports) of Fuel in 1983 to that in 1984?
Give a very brief answer. 1.28. What is the ratio of the Amount of exports(as % of merchandise exports) in Agricultural raw materials in 1983 to that in 1985?
Provide a short and direct response. 1.02. What is the ratio of the Amount of exports(as % of merchandise exports) in Food in 1983 to that in 1985?
Your answer should be very brief. 1.12. What is the ratio of the Amount of exports(as % of merchandise exports) in Fuel in 1983 to that in 1985?
Give a very brief answer. 0.64. What is the ratio of the Amount of exports(as % of merchandise exports) in Agricultural raw materials in 1984 to that in 1985?
Provide a succinct answer. 1. What is the ratio of the Amount of exports(as % of merchandise exports) in Food in 1984 to that in 1985?
Offer a terse response. 0.94. What is the ratio of the Amount of exports(as % of merchandise exports) in Fuel in 1984 to that in 1985?
Provide a short and direct response. 0.5. What is the difference between the highest and the second highest Amount of exports(as % of merchandise exports) in Agricultural raw materials?
Keep it short and to the point. 0.11. What is the difference between the highest and the second highest Amount of exports(as % of merchandise exports) of Food?
Your answer should be very brief. 1.43. What is the difference between the highest and the second highest Amount of exports(as % of merchandise exports) in Fuel?
Ensure brevity in your answer.  0.01. What is the difference between the highest and the lowest Amount of exports(as % of merchandise exports) of Agricultural raw materials?
Give a very brief answer. 1.17. What is the difference between the highest and the lowest Amount of exports(as % of merchandise exports) of Food?
Your answer should be compact. 2.16. What is the difference between the highest and the lowest Amount of exports(as % of merchandise exports) in Fuel?
Offer a terse response. 0.02. 